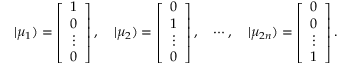<formula> <loc_0><loc_0><loc_500><loc_500>| \mu _ { 1 } ) = \left [ \begin{array} { c } { 1 } \\ { 0 } \\ { \vdots } \\ { 0 } \end{array} \right ] , \quad | \mu _ { 2 } ) = \left [ \begin{array} { c } { 0 } \\ { 1 } \\ { \vdots } \\ { 0 } \end{array} \right ] , \quad \cdots , \quad | \mu _ { 2 n } ) = \left [ \begin{array} { c } { 0 } \\ { 0 } \\ { \vdots } \\ { 1 } \end{array} \right ] .</formula> 